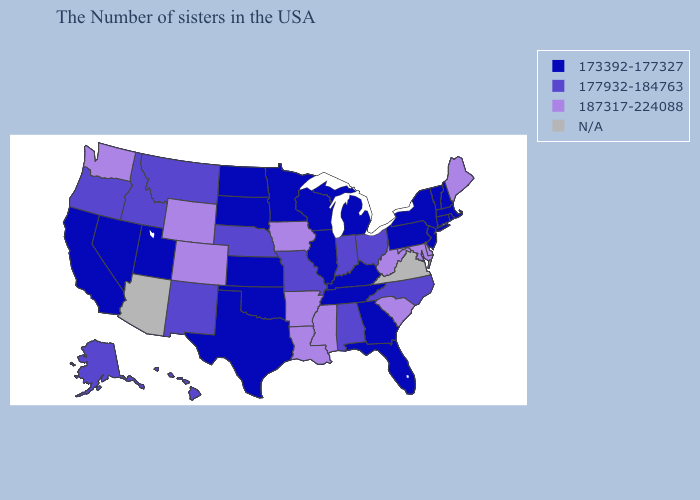What is the value of Mississippi?
Short answer required. 187317-224088. Among the states that border New Mexico , which have the highest value?
Give a very brief answer. Colorado. What is the value of Minnesota?
Be succinct. 173392-177327. Name the states that have a value in the range 173392-177327?
Answer briefly. Massachusetts, Rhode Island, New Hampshire, Vermont, Connecticut, New York, New Jersey, Pennsylvania, Florida, Georgia, Michigan, Kentucky, Tennessee, Wisconsin, Illinois, Minnesota, Kansas, Oklahoma, Texas, South Dakota, North Dakota, Utah, Nevada, California. Which states have the lowest value in the USA?
Concise answer only. Massachusetts, Rhode Island, New Hampshire, Vermont, Connecticut, New York, New Jersey, Pennsylvania, Florida, Georgia, Michigan, Kentucky, Tennessee, Wisconsin, Illinois, Minnesota, Kansas, Oklahoma, Texas, South Dakota, North Dakota, Utah, Nevada, California. Which states have the lowest value in the USA?
Write a very short answer. Massachusetts, Rhode Island, New Hampshire, Vermont, Connecticut, New York, New Jersey, Pennsylvania, Florida, Georgia, Michigan, Kentucky, Tennessee, Wisconsin, Illinois, Minnesota, Kansas, Oklahoma, Texas, South Dakota, North Dakota, Utah, Nevada, California. What is the lowest value in the South?
Write a very short answer. 173392-177327. Which states hav the highest value in the West?
Give a very brief answer. Wyoming, Colorado, Washington. What is the highest value in the MidWest ?
Quick response, please. 187317-224088. Name the states that have a value in the range N/A?
Short answer required. Virginia, Arizona. What is the lowest value in the USA?
Quick response, please. 173392-177327. What is the value of Arizona?
Answer briefly. N/A. Does Massachusetts have the highest value in the Northeast?
Give a very brief answer. No. What is the value of Tennessee?
Answer briefly. 173392-177327. 